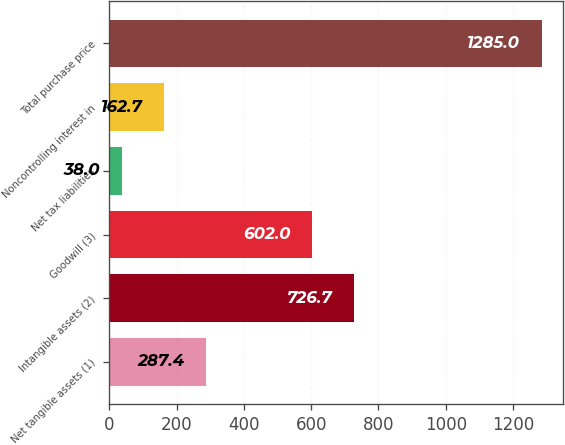<chart> <loc_0><loc_0><loc_500><loc_500><bar_chart><fcel>Net tangible assets (1)<fcel>Intangible assets (2)<fcel>Goodwill (3)<fcel>Net tax liabilities<fcel>Noncontrolling interest in<fcel>Total purchase price<nl><fcel>287.4<fcel>726.7<fcel>602<fcel>38<fcel>162.7<fcel>1285<nl></chart> 